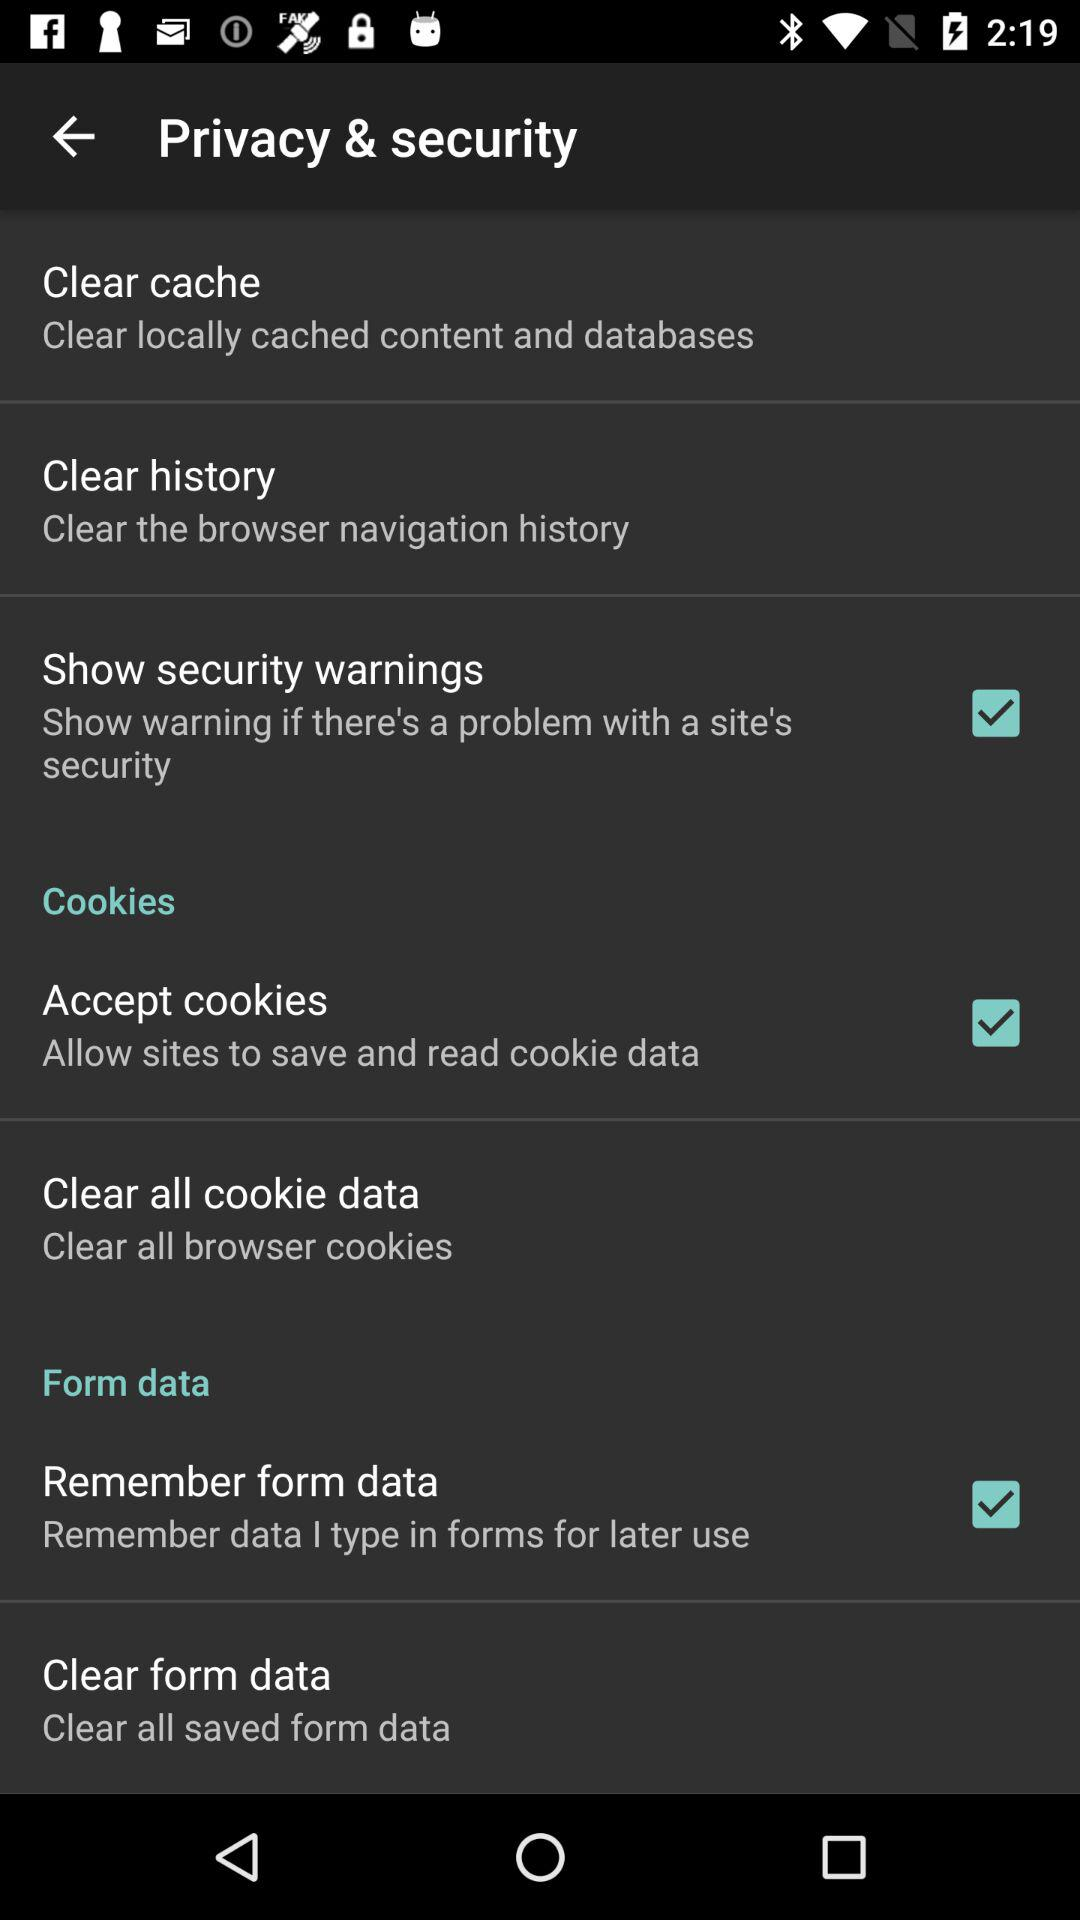When will the user be warned about security? The user will be warned about security issues directly related to the settings enabled in the 'Privacy & security' section as depicted in the screenshot. Specifically, the user has enabled 'Show security warnings', which alerts them whenever there's a problem with a site's security, such as unreliable certificates or unsafe connections. 